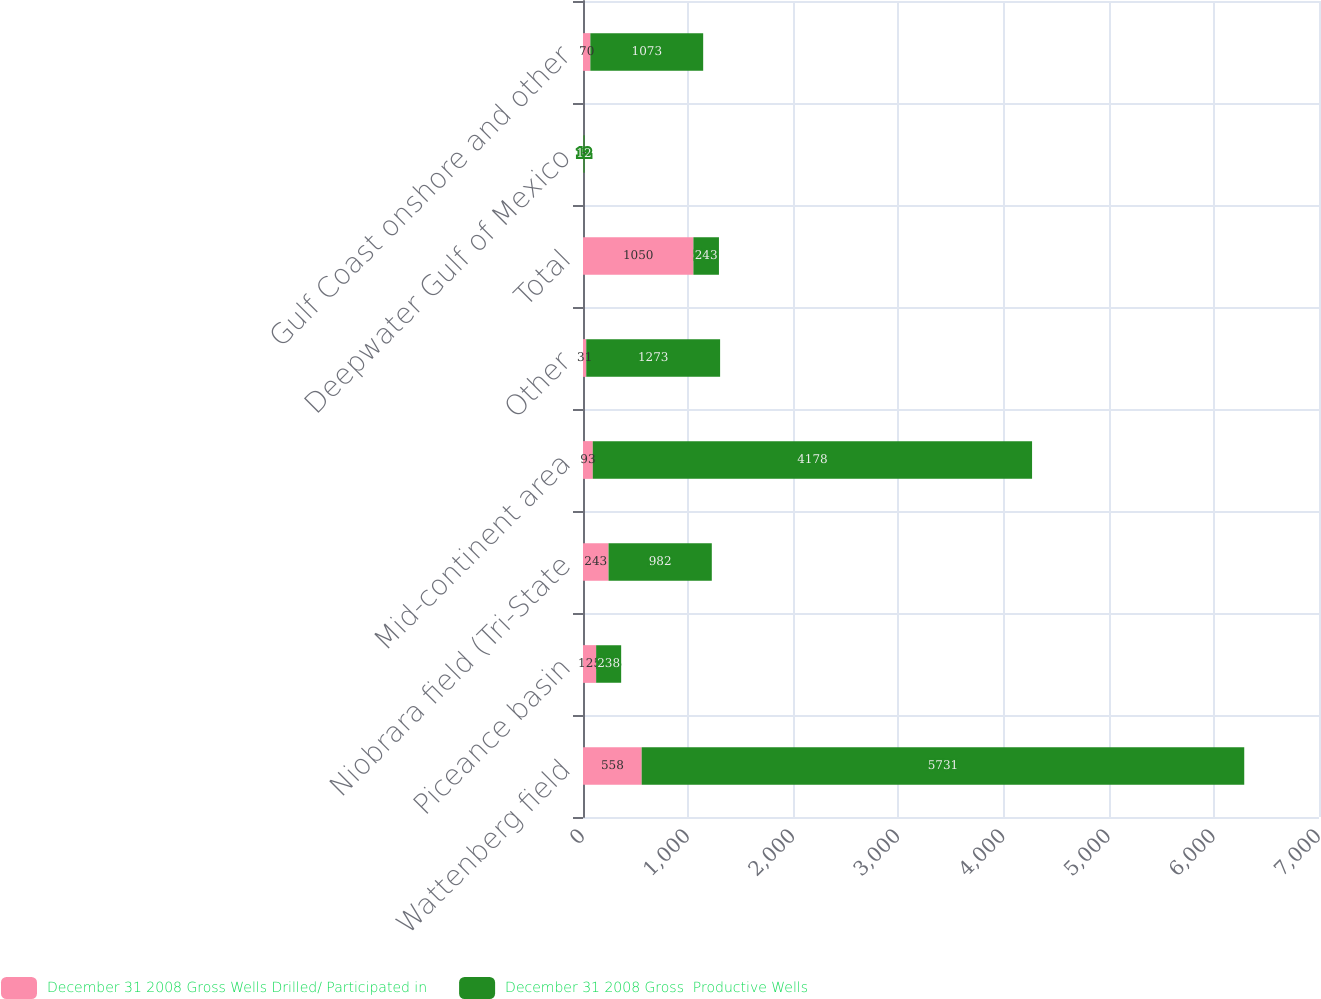Convert chart. <chart><loc_0><loc_0><loc_500><loc_500><stacked_bar_chart><ecel><fcel>Wattenberg field<fcel>Piceance basin<fcel>Niobrara field (Tri-State<fcel>Mid-continent area<fcel>Other<fcel>Total<fcel>Deepwater Gulf of Mexico<fcel>Gulf Coast onshore and other<nl><fcel>December 31 2008 Gross Wells Drilled/ Participated in<fcel>558<fcel>125<fcel>243<fcel>93<fcel>31<fcel>1050<fcel>3<fcel>70<nl><fcel>December 31 2008 Gross  Productive Wells<fcel>5731<fcel>238<fcel>982<fcel>4178<fcel>1273<fcel>243<fcel>12<fcel>1073<nl></chart> 